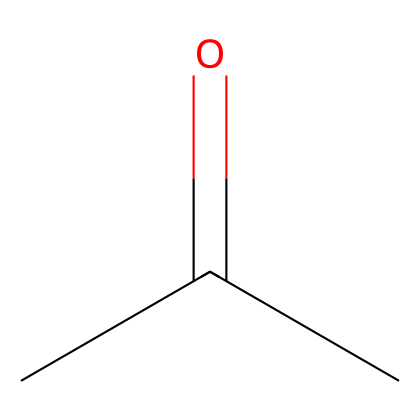What is the molecular formula of the compound represented? The SMILES notation CC(=O)C represents a compound with three carbon atoms, one oxygen atom in the carbonyl group, and the remaining hydrogen atoms balanced. Thus, the molecular formula can be derived as C3H6O.
Answer: C3H6O How many carbon atoms are present in this molecule? The molecule's structure begins with "CC" which indicates two carbon atoms connected, and the carbonyl group brings the total to three carbon atoms.
Answer: 3 What is the functional group present in the structure? The "=O" in the SMILES indicates the presence of a carbonyl group (C=O), which is the functional group that characterizes ketones, like acetone.
Answer: carbonyl Is this compound a polar or nonpolar solvent? The presence of the polar carbonyl group (C=O) suggests that the molecule has polar characteristics, balancing out with its hydrophobic carbon chains, generally making it a polar solvent.
Answer: polar For what purpose is this solvent commonly used? Acetone is widely recognized for its use in DNA extraction from animal tissues, as it effectively precipitates nucleic acids, separating them from proteins and other cellular debris.
Answer: DNA extraction What type of solvent is acetone classified as? Acetone is classified as a ketone due to its specific structure where the carbonyl group is flanked by carbon atoms. This classification helps explain its solvent properties.
Answer: ketone 